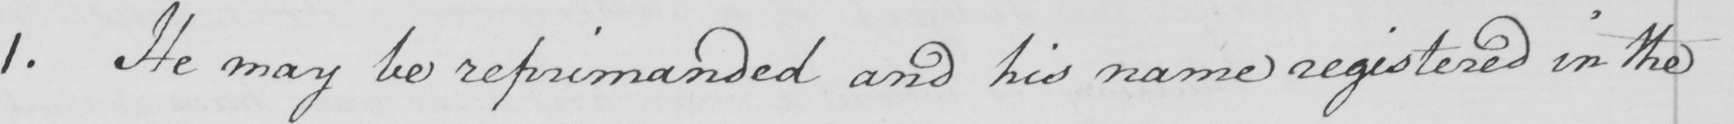Please provide the text content of this handwritten line. 1 . He may be reprimanded and his name registered in the 